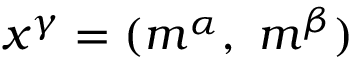Convert formula to latex. <formula><loc_0><loc_0><loc_500><loc_500>x ^ { \gamma } = ( m ^ { \alpha } , m ^ { \beta } )</formula> 